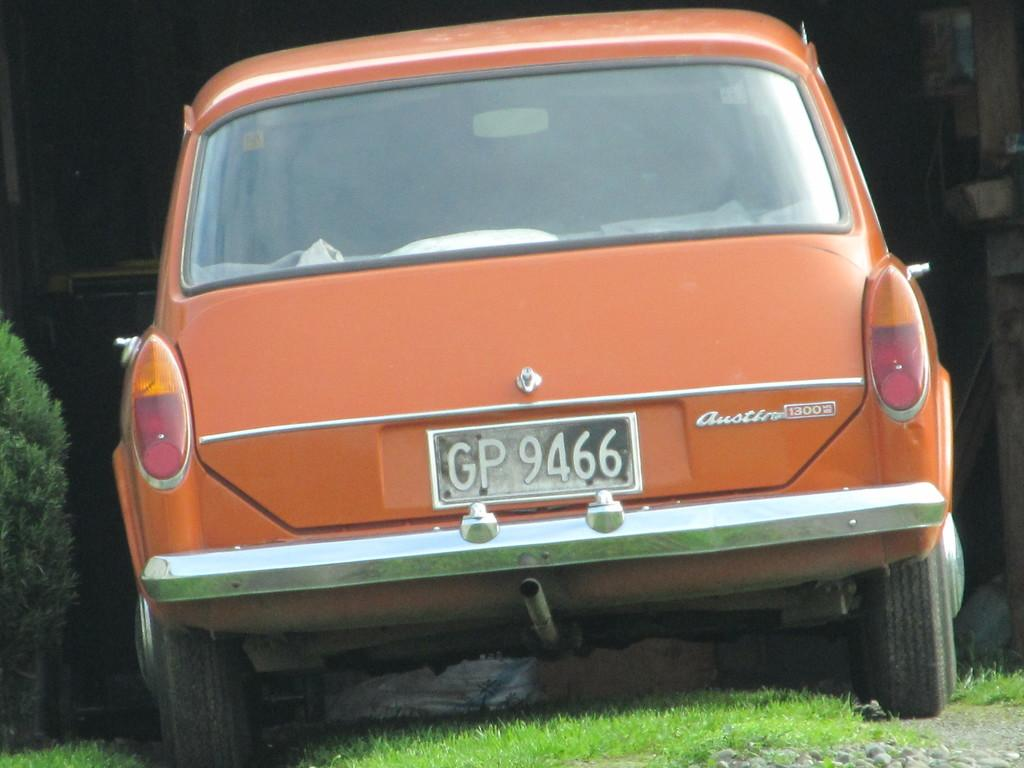What is the main subject in the center of the image? There is a car in the center of the image. What type of natural environment is visible at the bottom of the image? There is grass at the bottom of the image. What other vegetation can be seen on the left side of the image? There is a bush on the left side of the image. What type of appliance can be seen in the image? There is no appliance present in the image. What fictional character is interacting with the car in the image? There are no fictional characters present in the image. 